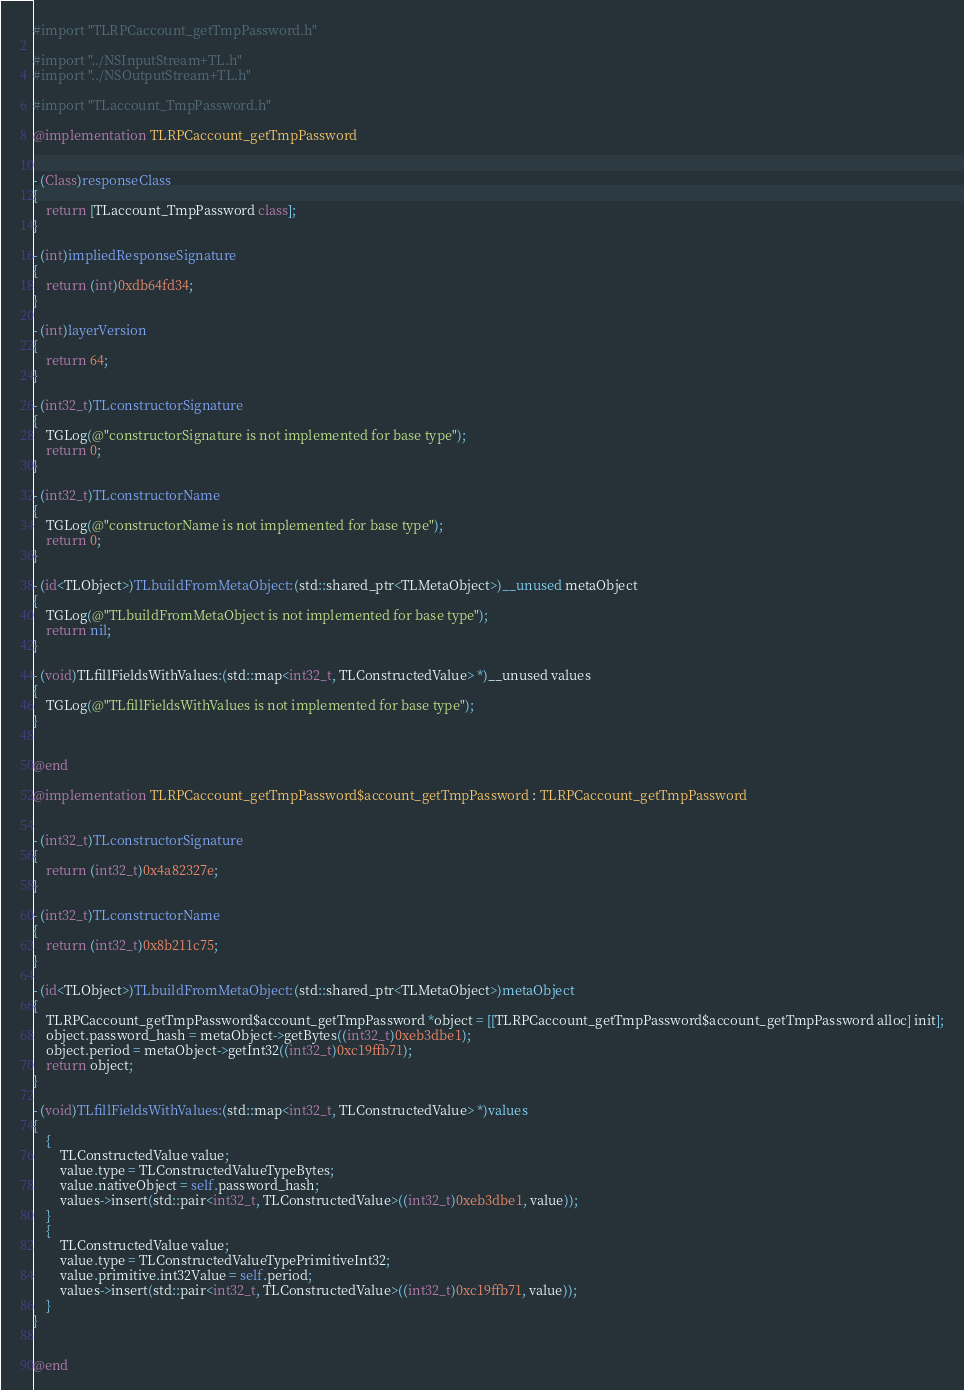<code> <loc_0><loc_0><loc_500><loc_500><_ObjectiveC_>#import "TLRPCaccount_getTmpPassword.h"

#import "../NSInputStream+TL.h"
#import "../NSOutputStream+TL.h"

#import "TLaccount_TmpPassword.h"

@implementation TLRPCaccount_getTmpPassword


- (Class)responseClass
{
    return [TLaccount_TmpPassword class];
}

- (int)impliedResponseSignature
{
    return (int)0xdb64fd34;
}

- (int)layerVersion
{
    return 64;
}

- (int32_t)TLconstructorSignature
{
    TGLog(@"constructorSignature is not implemented for base type");
    return 0;
}

- (int32_t)TLconstructorName
{
    TGLog(@"constructorName is not implemented for base type");
    return 0;
}

- (id<TLObject>)TLbuildFromMetaObject:(std::shared_ptr<TLMetaObject>)__unused metaObject
{
    TGLog(@"TLbuildFromMetaObject is not implemented for base type");
    return nil;
}

- (void)TLfillFieldsWithValues:(std::map<int32_t, TLConstructedValue> *)__unused values
{
    TGLog(@"TLfillFieldsWithValues is not implemented for base type");
}


@end

@implementation TLRPCaccount_getTmpPassword$account_getTmpPassword : TLRPCaccount_getTmpPassword


- (int32_t)TLconstructorSignature
{
    return (int32_t)0x4a82327e;
}

- (int32_t)TLconstructorName
{
    return (int32_t)0x8b211c75;
}

- (id<TLObject>)TLbuildFromMetaObject:(std::shared_ptr<TLMetaObject>)metaObject
{
    TLRPCaccount_getTmpPassword$account_getTmpPassword *object = [[TLRPCaccount_getTmpPassword$account_getTmpPassword alloc] init];
    object.password_hash = metaObject->getBytes((int32_t)0xeb3dbe1);
    object.period = metaObject->getInt32((int32_t)0xc19ffb71);
    return object;
}

- (void)TLfillFieldsWithValues:(std::map<int32_t, TLConstructedValue> *)values
{
    {
        TLConstructedValue value;
        value.type = TLConstructedValueTypeBytes;
        value.nativeObject = self.password_hash;
        values->insert(std::pair<int32_t, TLConstructedValue>((int32_t)0xeb3dbe1, value));
    }
    {
        TLConstructedValue value;
        value.type = TLConstructedValueTypePrimitiveInt32;
        value.primitive.int32Value = self.period;
        values->insert(std::pair<int32_t, TLConstructedValue>((int32_t)0xc19ffb71, value));
    }
}


@end

</code> 